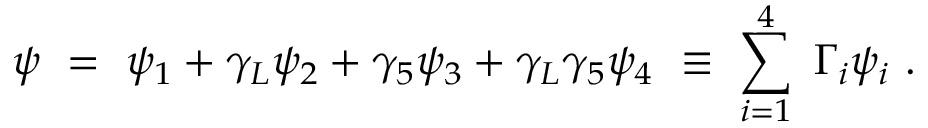<formula> <loc_0><loc_0><loc_500><loc_500>\psi \ = \ \psi _ { 1 } + \gamma _ { L } \psi _ { 2 } + \gamma _ { 5 } \psi _ { 3 } + \gamma _ { L } \gamma _ { 5 } \psi _ { 4 } \ \equiv \ \sum _ { i = 1 } ^ { 4 } \ \Gamma _ { i } \psi _ { i } \ .</formula> 